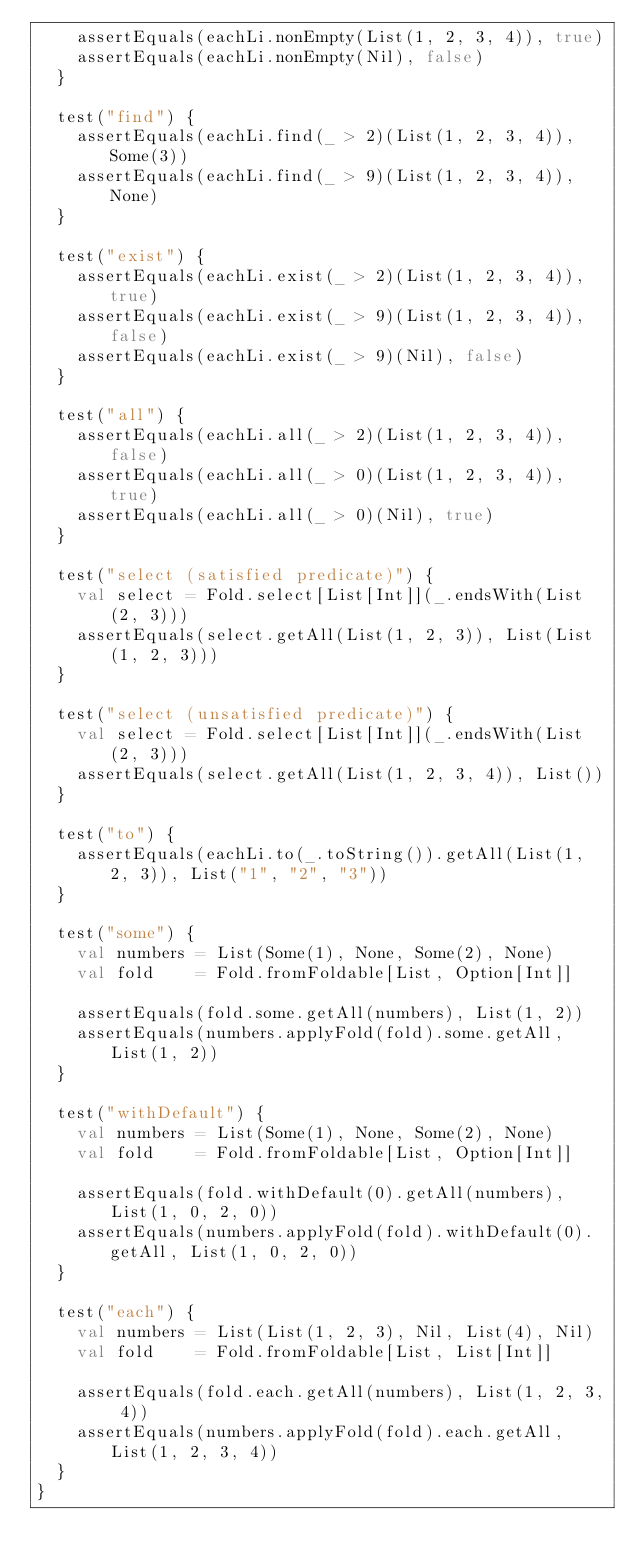Convert code to text. <code><loc_0><loc_0><loc_500><loc_500><_Scala_>    assertEquals(eachLi.nonEmpty(List(1, 2, 3, 4)), true)
    assertEquals(eachLi.nonEmpty(Nil), false)
  }

  test("find") {
    assertEquals(eachLi.find(_ > 2)(List(1, 2, 3, 4)), Some(3))
    assertEquals(eachLi.find(_ > 9)(List(1, 2, 3, 4)), None)
  }

  test("exist") {
    assertEquals(eachLi.exist(_ > 2)(List(1, 2, 3, 4)), true)
    assertEquals(eachLi.exist(_ > 9)(List(1, 2, 3, 4)), false)
    assertEquals(eachLi.exist(_ > 9)(Nil), false)
  }

  test("all") {
    assertEquals(eachLi.all(_ > 2)(List(1, 2, 3, 4)), false)
    assertEquals(eachLi.all(_ > 0)(List(1, 2, 3, 4)), true)
    assertEquals(eachLi.all(_ > 0)(Nil), true)
  }

  test("select (satisfied predicate)") {
    val select = Fold.select[List[Int]](_.endsWith(List(2, 3)))
    assertEquals(select.getAll(List(1, 2, 3)), List(List(1, 2, 3)))
  }

  test("select (unsatisfied predicate)") {
    val select = Fold.select[List[Int]](_.endsWith(List(2, 3)))
    assertEquals(select.getAll(List(1, 2, 3, 4)), List())
  }

  test("to") {
    assertEquals(eachLi.to(_.toString()).getAll(List(1, 2, 3)), List("1", "2", "3"))
  }

  test("some") {
    val numbers = List(Some(1), None, Some(2), None)
    val fold    = Fold.fromFoldable[List, Option[Int]]

    assertEquals(fold.some.getAll(numbers), List(1, 2))
    assertEquals(numbers.applyFold(fold).some.getAll, List(1, 2))
  }

  test("withDefault") {
    val numbers = List(Some(1), None, Some(2), None)
    val fold    = Fold.fromFoldable[List, Option[Int]]

    assertEquals(fold.withDefault(0).getAll(numbers), List(1, 0, 2, 0))
    assertEquals(numbers.applyFold(fold).withDefault(0).getAll, List(1, 0, 2, 0))
  }

  test("each") {
    val numbers = List(List(1, 2, 3), Nil, List(4), Nil)
    val fold    = Fold.fromFoldable[List, List[Int]]

    assertEquals(fold.each.getAll(numbers), List(1, 2, 3, 4))
    assertEquals(numbers.applyFold(fold).each.getAll, List(1, 2, 3, 4))
  }
}
</code> 